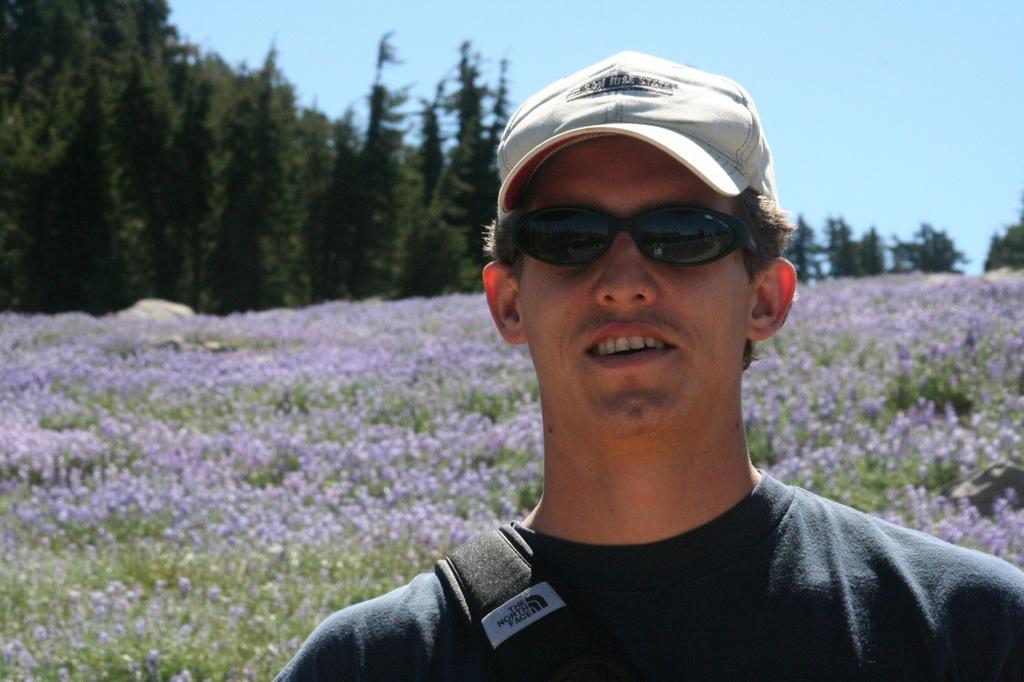Who is present in the image? There is a man in the picture. What is the man wearing on his head? The man is wearing a cap. What type of eyewear is the man wearing? The man is wearing goggles. What expression does the man have? The man is smiling. What type of vegetation can be seen in the background? There are flowers and trees visible in the background. What part of the natural environment is visible in the background? The sky is visible in the background. What type of pancake is the man flipping in the image? There is no pancake present in the image; the man is wearing goggles and a cap while smiling. 